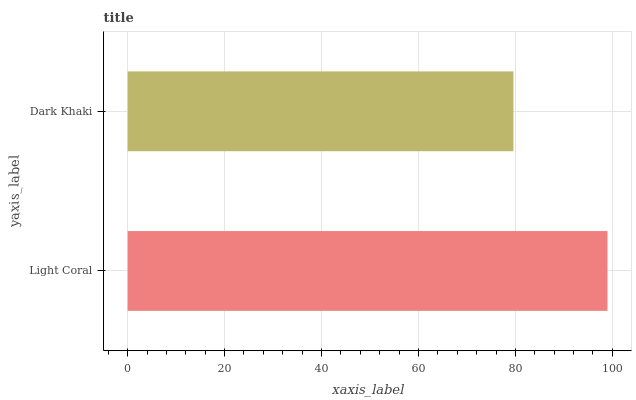Is Dark Khaki the minimum?
Answer yes or no. Yes. Is Light Coral the maximum?
Answer yes or no. Yes. Is Dark Khaki the maximum?
Answer yes or no. No. Is Light Coral greater than Dark Khaki?
Answer yes or no. Yes. Is Dark Khaki less than Light Coral?
Answer yes or no. Yes. Is Dark Khaki greater than Light Coral?
Answer yes or no. No. Is Light Coral less than Dark Khaki?
Answer yes or no. No. Is Light Coral the high median?
Answer yes or no. Yes. Is Dark Khaki the low median?
Answer yes or no. Yes. Is Dark Khaki the high median?
Answer yes or no. No. Is Light Coral the low median?
Answer yes or no. No. 